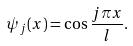Convert formula to latex. <formula><loc_0><loc_0><loc_500><loc_500>\psi _ { j } ( x ) = \cos \frac { j \pi x } { l } .</formula> 